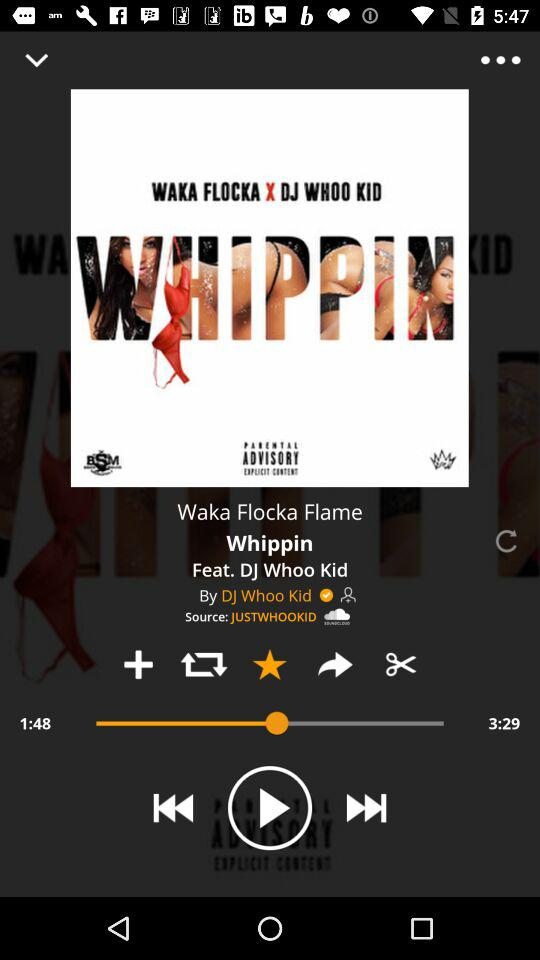What is the duration of the song? The duration of the song is 3 minutes 29 seconds. 